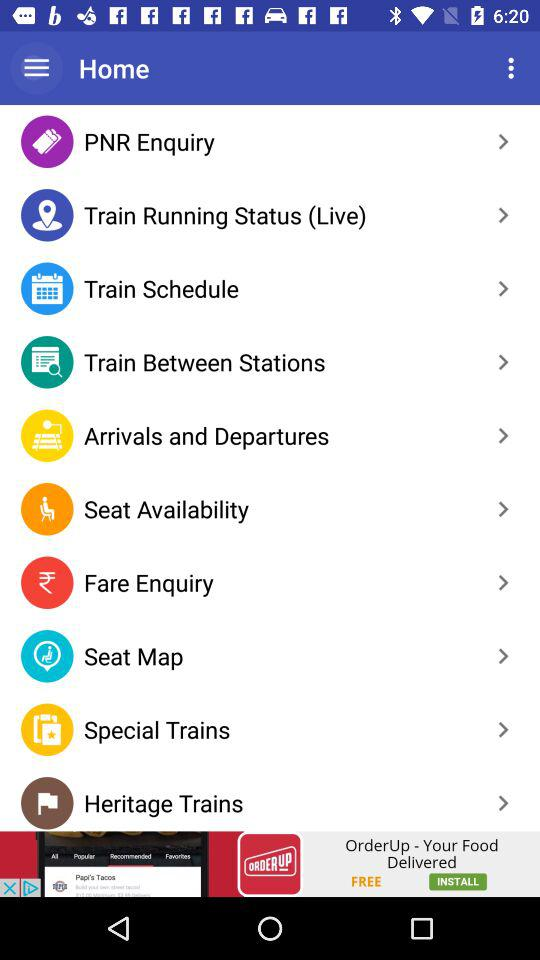Which version of the application is running now?
When the provided information is insufficient, respond with <no answer>. <no answer> 